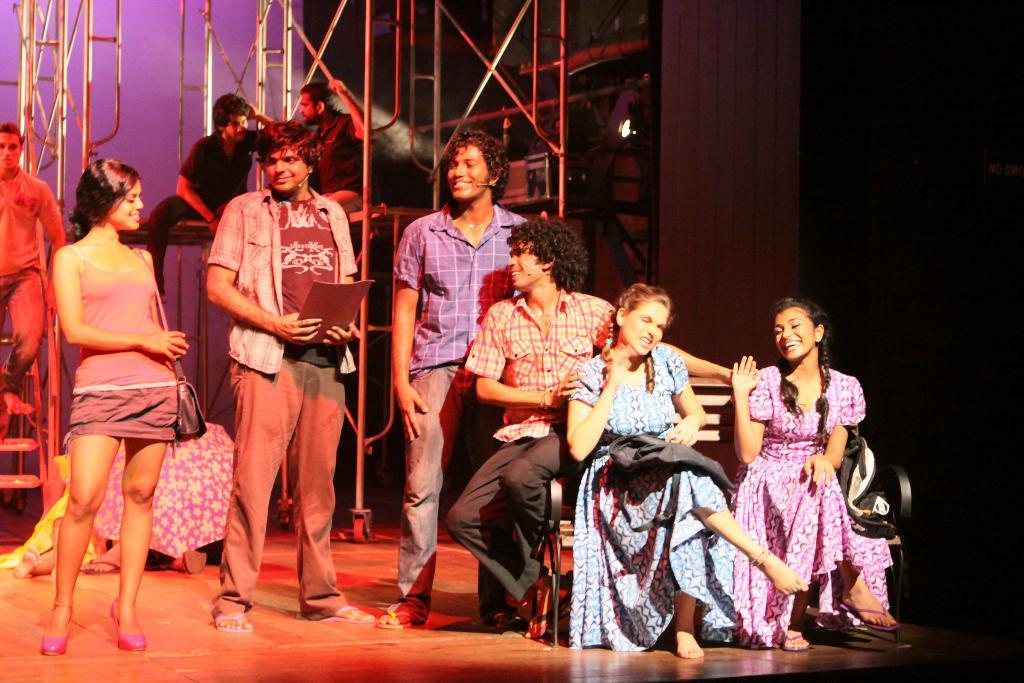Can you describe this image briefly? On the right side of the image there are three people sitting on the bench. Beside them there are three standing on the floor and they were laughing. Behind them there are a few other people. In the background of the image there is a wall. There are metal rods. 